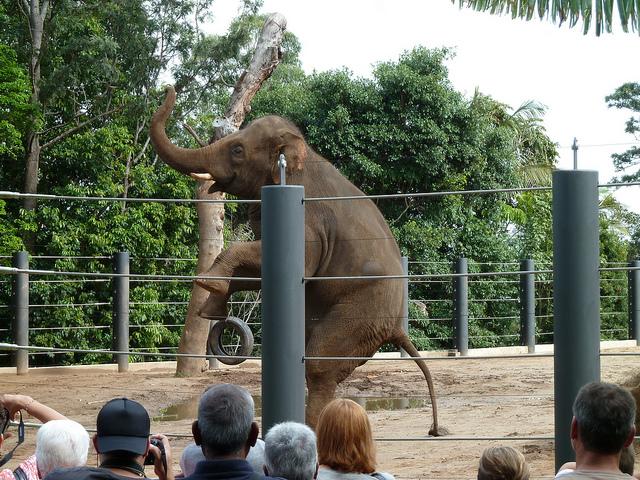Is the elephant dancing?
Keep it brief. Yes. Is it daylight?
Write a very short answer. Yes. Is the animal surrounded by a fence?
Give a very brief answer. Yes. 